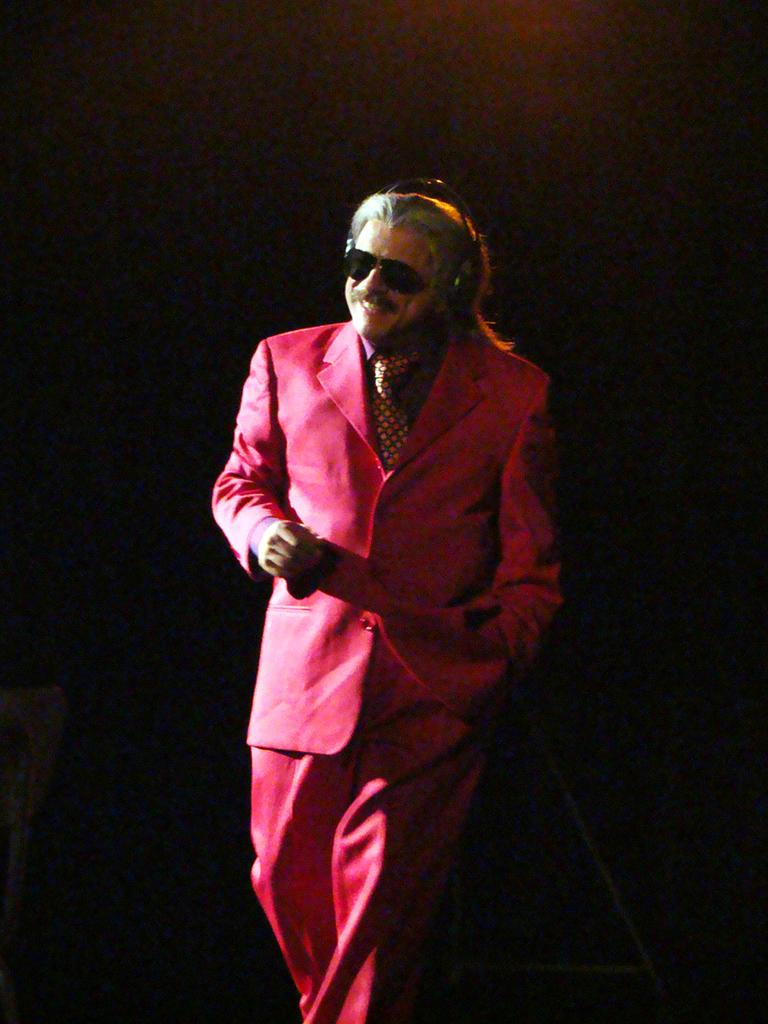Who is the main subject in the image? There is a man in the image. What is the man wearing? The man is wearing a red dress. What can be seen in the background of the image? The background of the image is dark. What type of pain does the man experience in the image? There is no indication of pain in the image; the man is simply wearing a red dress. What flavor of the red dress can be tasted in the image? The red dress is not edible, so there is no flavor to taste. 